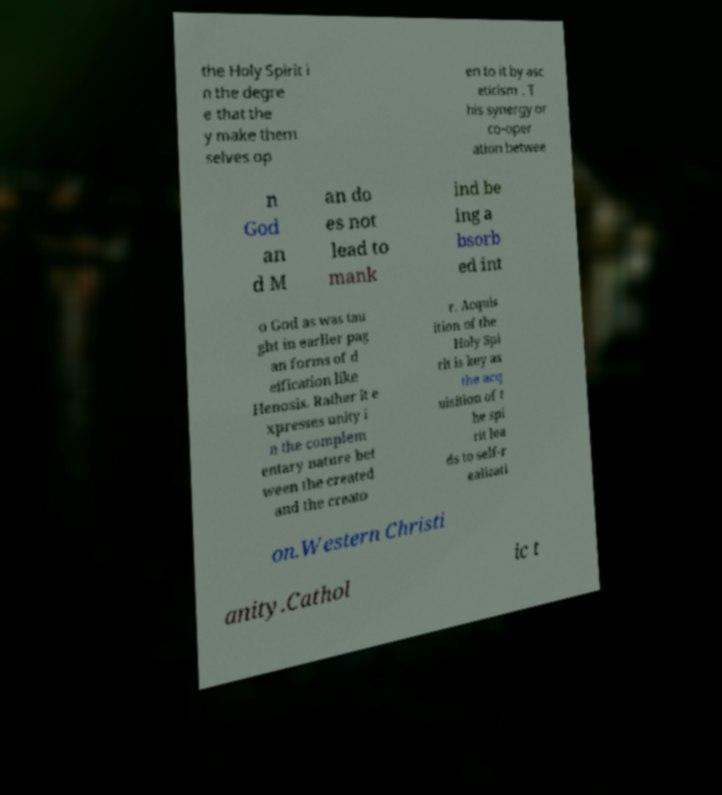Please identify and transcribe the text found in this image. the Holy Spirit i n the degre e that the y make them selves op en to it by asc eticism . T his synergy or co-oper ation betwee n God an d M an do es not lead to mank ind be ing a bsorb ed int o God as was tau ght in earlier pag an forms of d eification like Henosis. Rather it e xpresses unity i n the complem entary nature bet ween the created and the creato r. Acquis ition of the Holy Spi rit is key as the acq uisition of t he spi rit lea ds to self-r ealizati on.Western Christi anity.Cathol ic t 